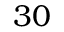Convert formula to latex. <formula><loc_0><loc_0><loc_500><loc_500>3 0</formula> 